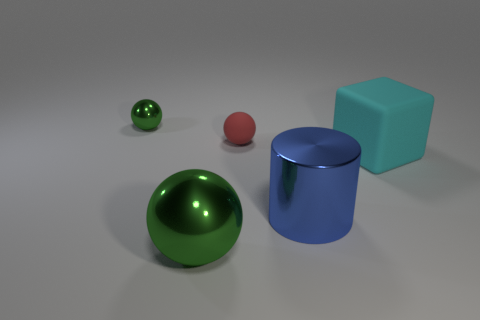Subtract all green balls. How many were subtracted if there are1green balls left? 1 Subtract all cyan cylinders. How many green balls are left? 2 Subtract all shiny spheres. How many spheres are left? 1 Subtract 1 balls. How many balls are left? 2 Add 1 green metallic cylinders. How many objects exist? 6 Subtract all cubes. How many objects are left? 4 Subtract all brown balls. Subtract all gray cubes. How many balls are left? 3 Add 3 large cylinders. How many large cylinders are left? 4 Add 1 small red rubber things. How many small red rubber things exist? 2 Subtract 1 cyan blocks. How many objects are left? 4 